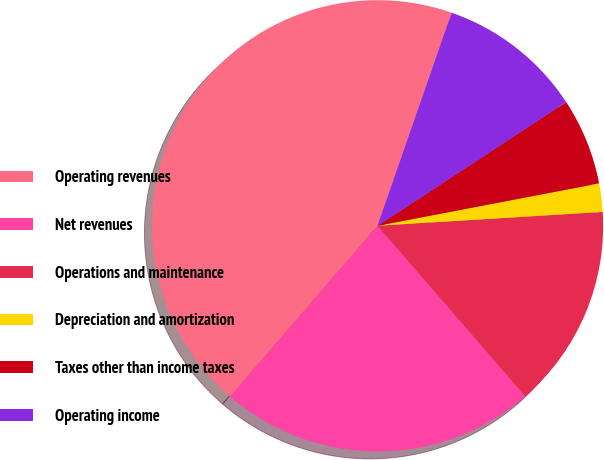Convert chart. <chart><loc_0><loc_0><loc_500><loc_500><pie_chart><fcel>Operating revenues<fcel>Net revenues<fcel>Operations and maintenance<fcel>Depreciation and amortization<fcel>Taxes other than income taxes<fcel>Operating income<nl><fcel>43.99%<fcel>22.7%<fcel>14.62%<fcel>2.03%<fcel>6.23%<fcel>10.43%<nl></chart> 